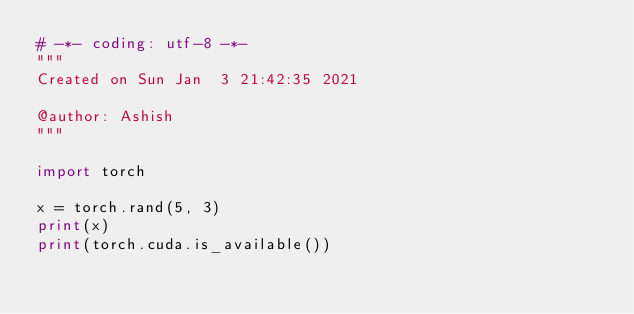Convert code to text. <code><loc_0><loc_0><loc_500><loc_500><_Python_># -*- coding: utf-8 -*-
"""
Created on Sun Jan  3 21:42:35 2021

@author: Ashish
"""

import torch

x = torch.rand(5, 3)
print(x)
print(torch.cuda.is_available())
</code> 